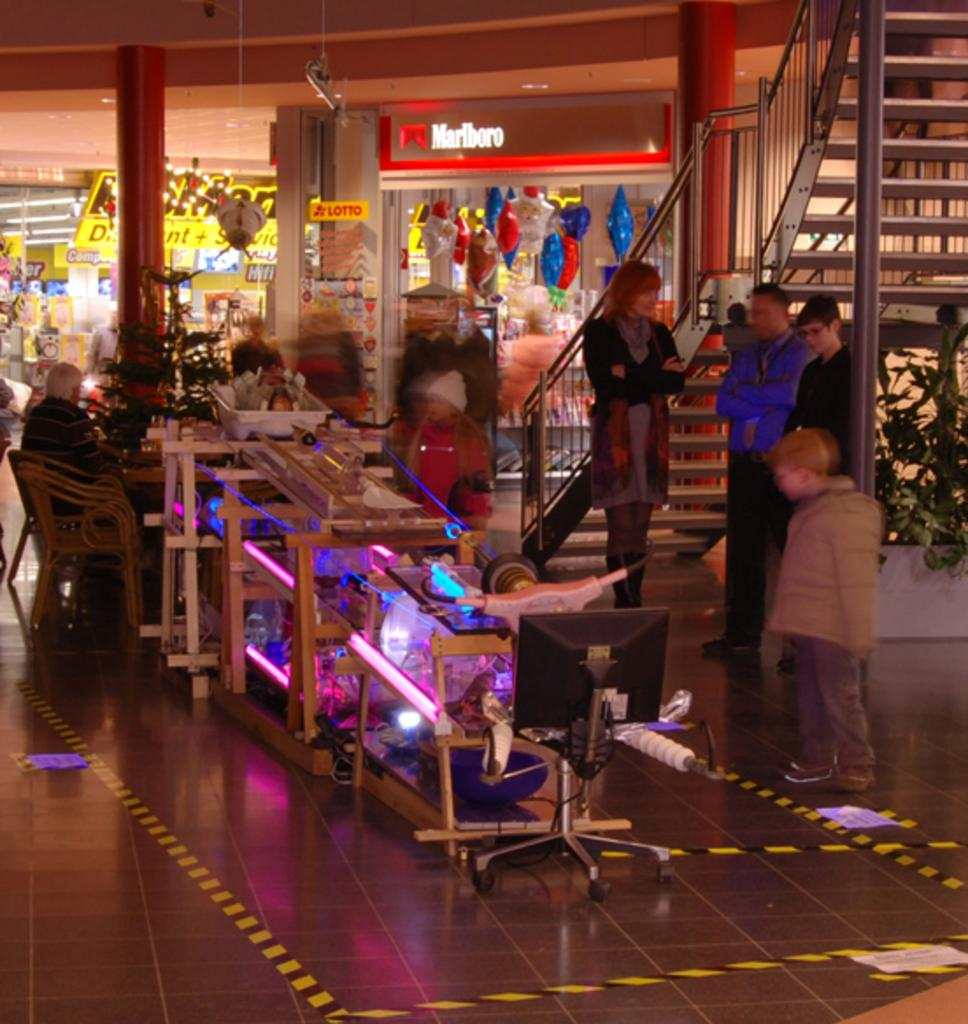How many people are present in the image? There is a group of people standing in the image. What architectural feature can be seen in the image? There are stairs in the image. What type of illumination is present in the image? There are lights in the image. What type of establishments are visible in the image? There are shops in the image. What type of signage is present in the image? There are boards in the image. What type of vegetation is present in the image? There are plants in the image. What type of seating is present in the image? There are chairs in the image. What type of objects are present in the image? There are some objects in the image. Can you tell me how many paper airplanes are flying in the image? There is no mention of paper airplanes in the image, so it cannot be determined how many, if any, are present. Are there any birds nesting in the plants in the image? There is no mention of birds or nests in the image, so it cannot be determined if any are present. 